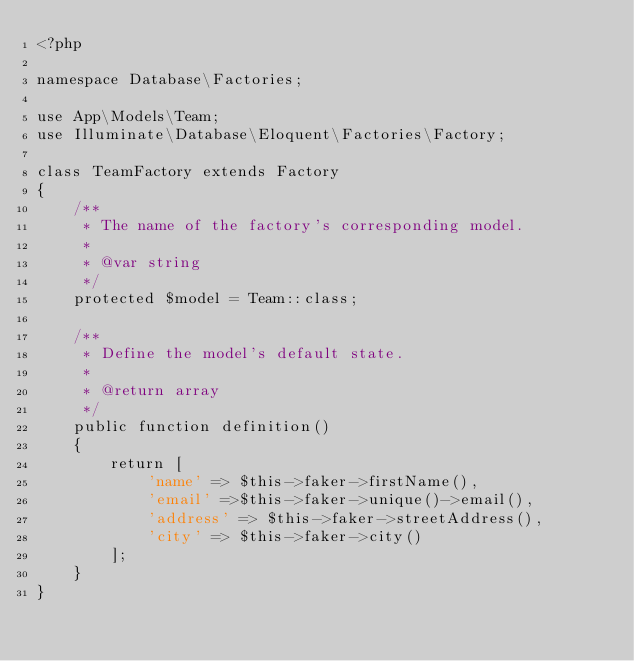<code> <loc_0><loc_0><loc_500><loc_500><_PHP_><?php

namespace Database\Factories;

use App\Models\Team;
use Illuminate\Database\Eloquent\Factories\Factory;

class TeamFactory extends Factory
{
    /**
     * The name of the factory's corresponding model.
     *
     * @var string
     */
    protected $model = Team::class;

    /**
     * Define the model's default state.
     *
     * @return array
     */
    public function definition()
    {
        return [
            'name' => $this->faker->firstName(),
            'email' =>$this->faker->unique()->email(),
            'address' => $this->faker->streetAddress(),
            'city' => $this->faker->city()
        ];
    }
}
</code> 